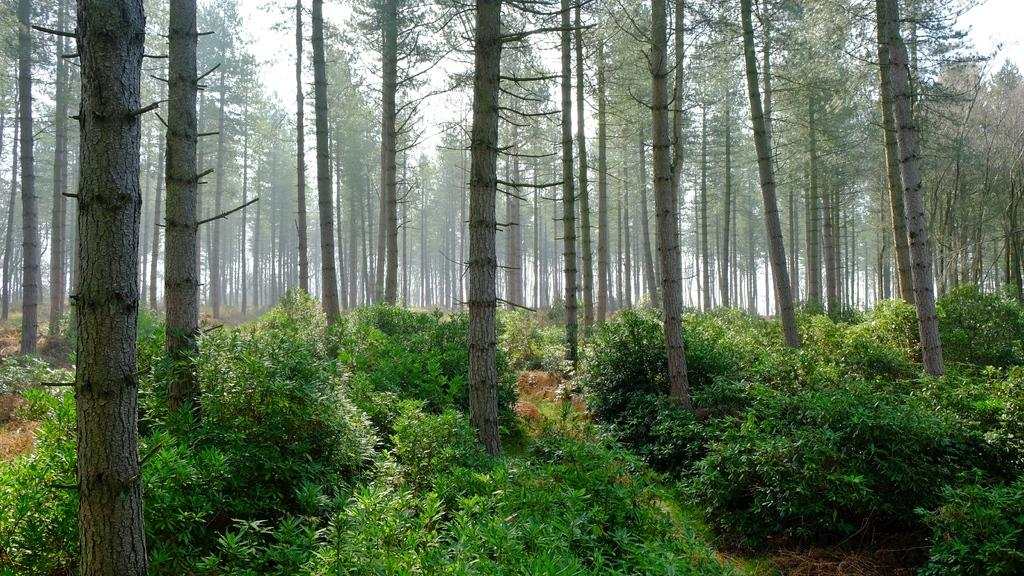What type of living organisms can be seen in the image? Plants and trees are visible in the image. How many trees can be seen in the image? There are many trees in the image. What is visible in the background of the image? The sky is visible in the background of the image. What type of cheese can be seen hanging from the trees in the image? There is no cheese present in the image; it features plants and trees with no mention of cheese. What type of shock can be seen affecting the plants in the image? There is no shock present in the image; the plants appear to be unaffected by any external factors. 